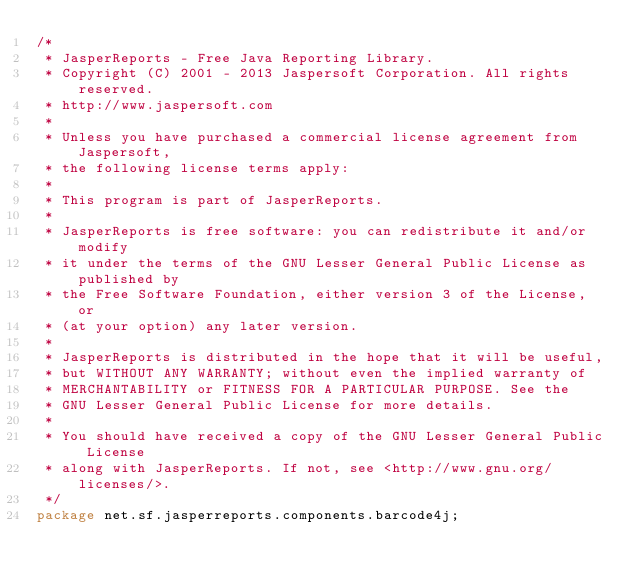Convert code to text. <code><loc_0><loc_0><loc_500><loc_500><_Java_>/*
 * JasperReports - Free Java Reporting Library.
 * Copyright (C) 2001 - 2013 Jaspersoft Corporation. All rights reserved.
 * http://www.jaspersoft.com
 *
 * Unless you have purchased a commercial license agreement from Jaspersoft,
 * the following license terms apply:
 *
 * This program is part of JasperReports.
 *
 * JasperReports is free software: you can redistribute it and/or modify
 * it under the terms of the GNU Lesser General Public License as published by
 * the Free Software Foundation, either version 3 of the License, or
 * (at your option) any later version.
 *
 * JasperReports is distributed in the hope that it will be useful,
 * but WITHOUT ANY WARRANTY; without even the implied warranty of
 * MERCHANTABILITY or FITNESS FOR A PARTICULAR PURPOSE. See the
 * GNU Lesser General Public License for more details.
 *
 * You should have received a copy of the GNU Lesser General Public License
 * along with JasperReports. If not, see <http://www.gnu.org/licenses/>.
 */
package net.sf.jasperreports.components.barcode4j;
</code> 